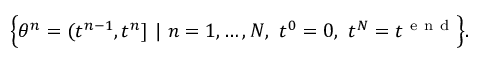<formula> <loc_0><loc_0><loc_500><loc_500>\left \{ \theta ^ { n } = ( t ^ { n - 1 } , t ^ { n } ] \ | \ n = 1 , \dots , N , \ t ^ { 0 } = 0 , \ t ^ { N } = t ^ { e n d } \right \} .</formula> 